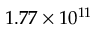Convert formula to latex. <formula><loc_0><loc_0><loc_500><loc_500>1 . 7 7 \times 1 0 ^ { 1 1 }</formula> 